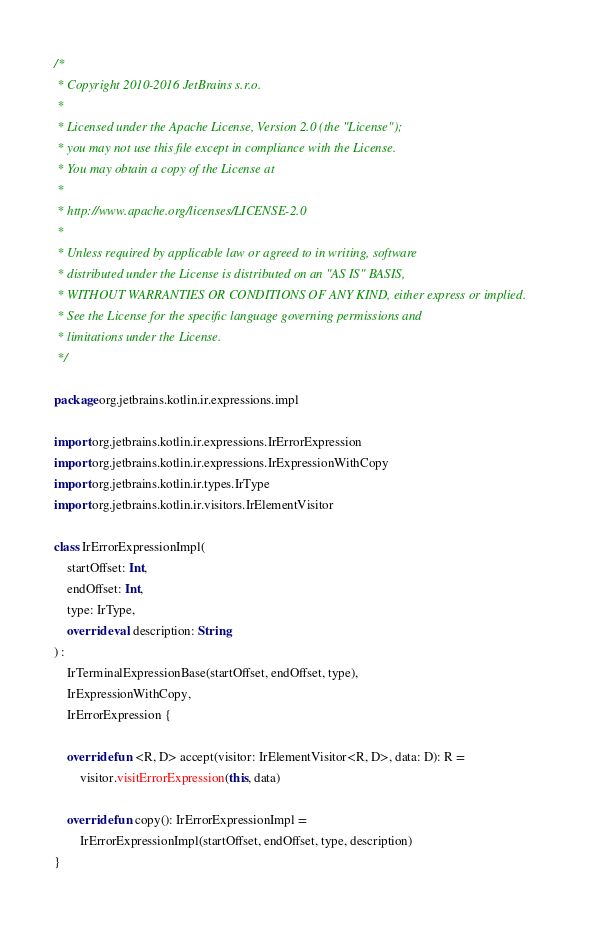<code> <loc_0><loc_0><loc_500><loc_500><_Kotlin_>/*
 * Copyright 2010-2016 JetBrains s.r.o.
 *
 * Licensed under the Apache License, Version 2.0 (the "License");
 * you may not use this file except in compliance with the License.
 * You may obtain a copy of the License at
 *
 * http://www.apache.org/licenses/LICENSE-2.0
 *
 * Unless required by applicable law or agreed to in writing, software
 * distributed under the License is distributed on an "AS IS" BASIS,
 * WITHOUT WARRANTIES OR CONDITIONS OF ANY KIND, either express or implied.
 * See the License for the specific language governing permissions and
 * limitations under the License.
 */

package org.jetbrains.kotlin.ir.expressions.impl

import org.jetbrains.kotlin.ir.expressions.IrErrorExpression
import org.jetbrains.kotlin.ir.expressions.IrExpressionWithCopy
import org.jetbrains.kotlin.ir.types.IrType
import org.jetbrains.kotlin.ir.visitors.IrElementVisitor

class IrErrorExpressionImpl(
    startOffset: Int,
    endOffset: Int,
    type: IrType,
    override val description: String
) :
    IrTerminalExpressionBase(startOffset, endOffset, type),
    IrExpressionWithCopy,
    IrErrorExpression {

    override fun <R, D> accept(visitor: IrElementVisitor<R, D>, data: D): R =
        visitor.visitErrorExpression(this, data)

    override fun copy(): IrErrorExpressionImpl =
        IrErrorExpressionImpl(startOffset, endOffset, type, description)
}</code> 